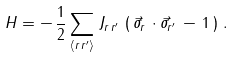<formula> <loc_0><loc_0><loc_500><loc_500>H = - \, \frac { 1 } { 2 } \sum _ { \langle r \, r ^ { \prime } \rangle } \, J _ { r \, r ^ { \prime } } \, \left ( \, \vec { \sigma } _ { r } \, \cdot \vec { \sigma } _ { r ^ { \prime } } \, - \, 1 \, \right ) \, .</formula> 